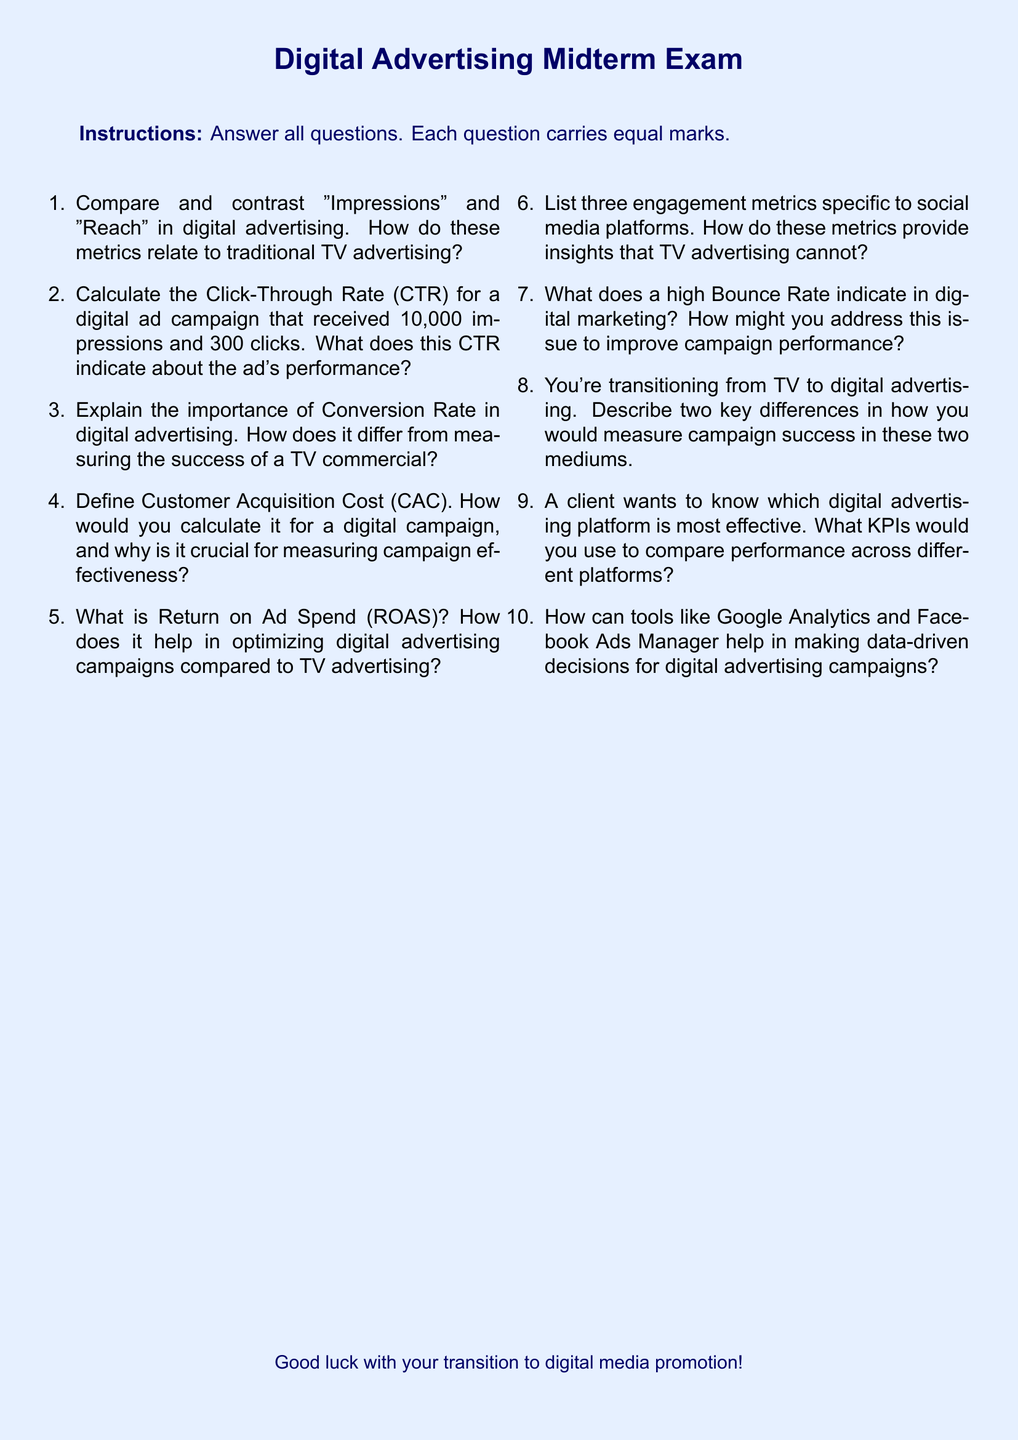what is the title of the document? The title of the document is indicated at the beginning and is "Digital Advertising Midterm Exam".
Answer: Digital Advertising Midterm Exam what is the total number of questions in the exam? The number of questions is listed as ten in the enumerated list provided.
Answer: 10 what metric is used to calculate the effectiveness of an ad campaign that received 10,000 impressions and 300 clicks? This information refers to the Click-Through Rate (CTR) which is mentioned in the context of the question.
Answer: Click-Through Rate (CTR) what does a high Bounce Rate indicate in digital marketing? The document states that a high Bounce Rate indicates a specific outcome related to user engagement, requiring analysis for improvement.
Answer: High Bounce Rate indicates user disengagement which tools are mentioned for making data-driven decisions for digital advertising campaigns? The document specifically lists two tools that are commonly used in digital advertising analytics: Google Analytics and Facebook Ads Manager.
Answer: Google Analytics and Facebook Ads Manager which metric shows how much it costs to acquire a new customer in digital advertising? The term describing this metric is defined in the document as Customer Acquisition Cost (CAC).
Answer: Customer Acquisition Cost (CAC) how many key differences in measuring campaign success between TV and digital advertising are suggested in the questions? The exam suggests that two key differences should be described, based on the context of the question.
Answer: 2 what is the purpose of Return on Ad Spend (ROAS) in digital advertising? The question explains that ROAS is used to help in optimizing ad campaigns, as mentioned in the exam content.
Answer: Optimizing ad campaigns what are engagement metrics specific to social media platforms? The question prompts the answer to list three specific engagement metrics related to social media, which are to be provided in the answer.
Answer: Three engagement metrics 